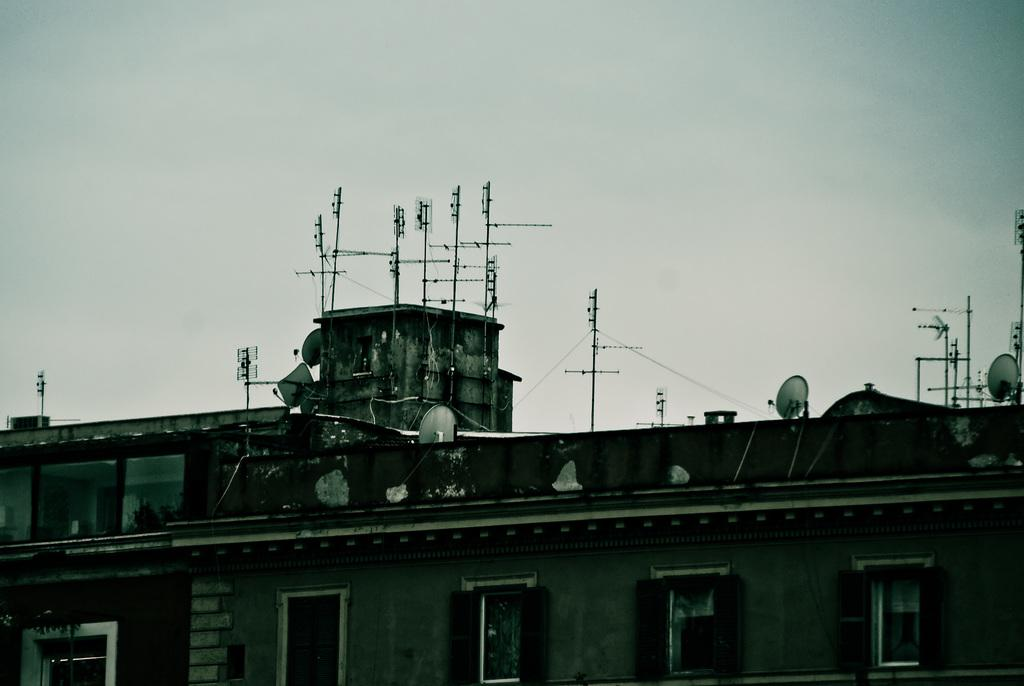What type of structures are present in the image? There are buildings with windows in the image. What can be seen on top of the buildings? There are poles on top of the buildings. What is visible in the sky in the background of the image? There are clouds visible in the sky in the background of the image. What type of honey is being produced by the cat in the image? There is no cat or honey present in the image. What crime is being committed in the image? There is no crime or criminal activity depicted in the image. 